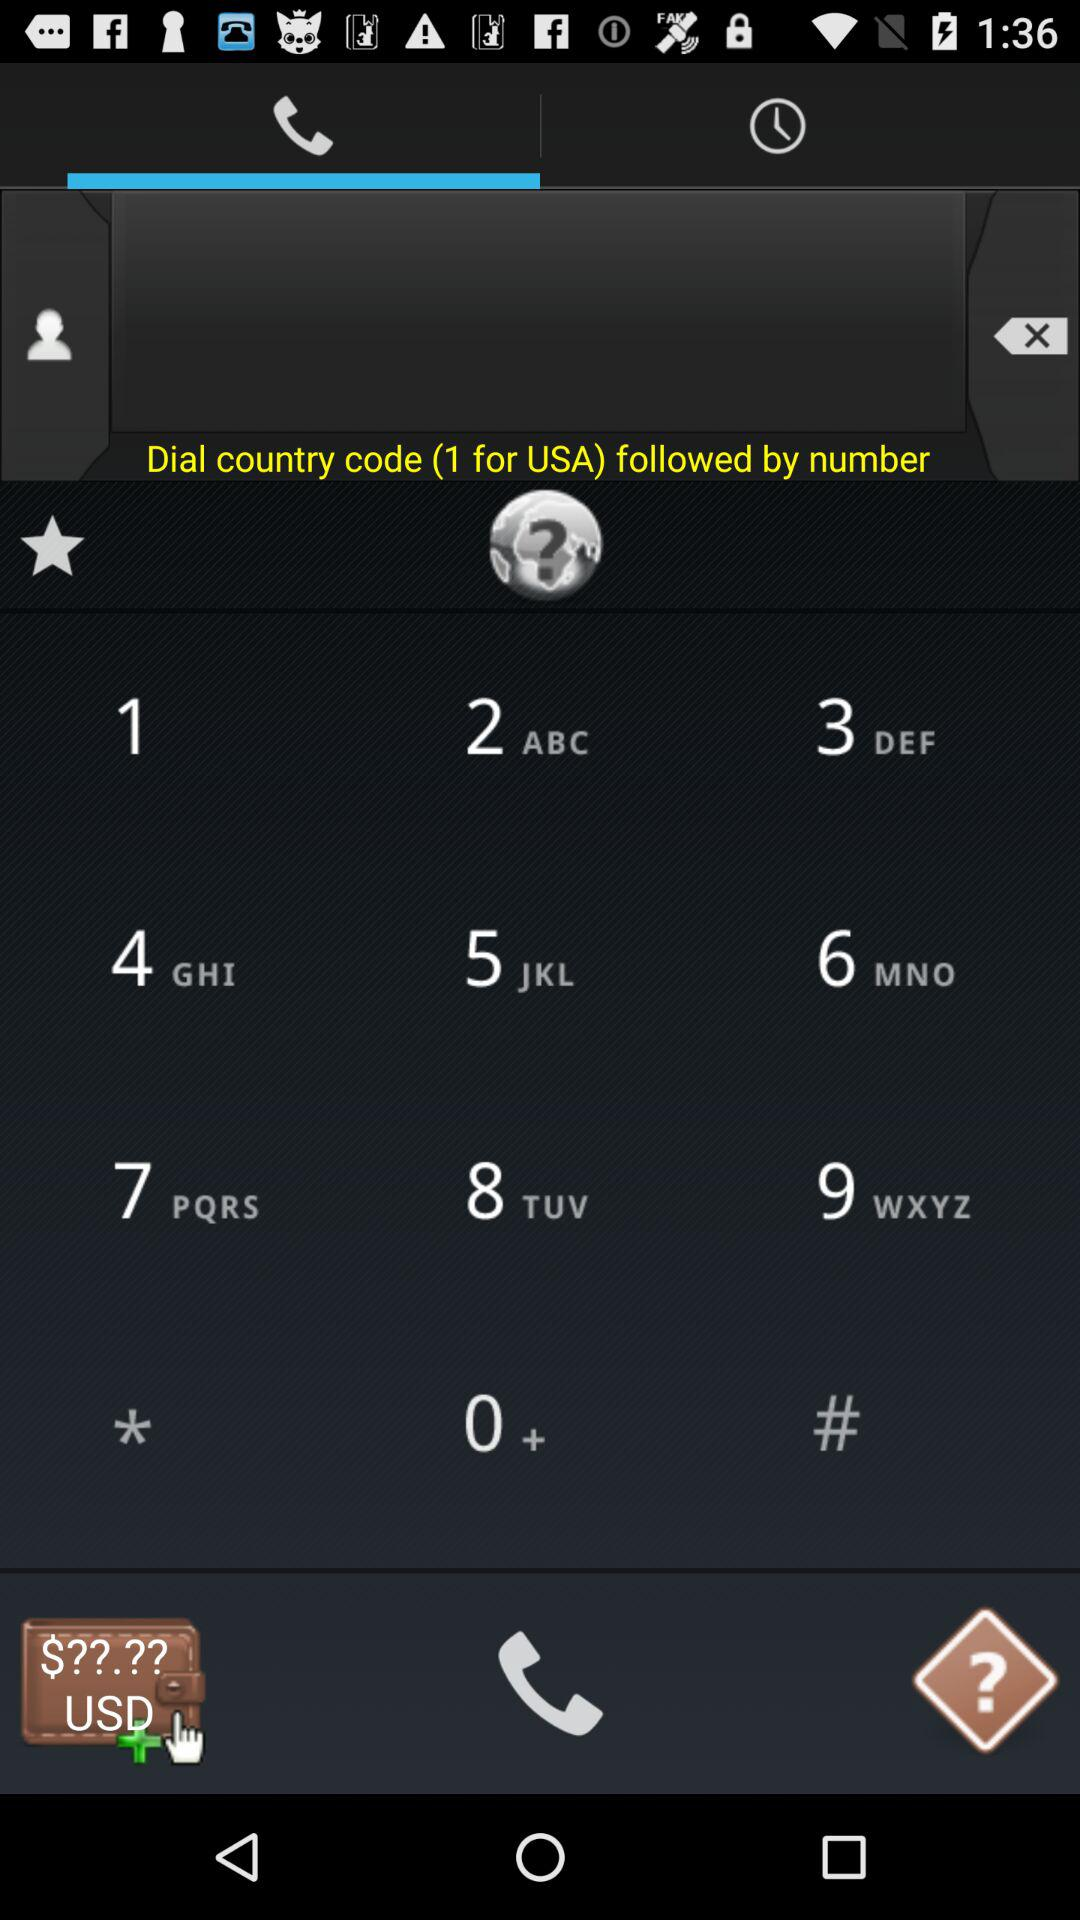Which tab is selected? The selected tab is "Dialer". 